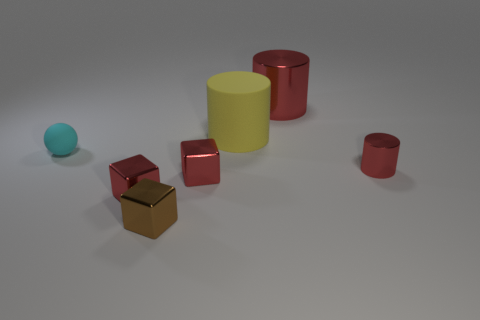Subtract all red cubes. How many were subtracted if there are1red cubes left? 1 Subtract all big yellow matte cylinders. How many cylinders are left? 2 Add 1 small blue matte blocks. How many objects exist? 8 Subtract all gray blocks. How many red cylinders are left? 2 Subtract all brown cubes. How many cubes are left? 2 Subtract all balls. How many objects are left? 6 Subtract all yellow blocks. Subtract all green cylinders. How many blocks are left? 3 Subtract all brown metallic things. Subtract all big red metal cylinders. How many objects are left? 5 Add 5 red metal objects. How many red metal objects are left? 9 Add 2 gray rubber spheres. How many gray rubber spheres exist? 2 